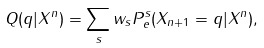<formula> <loc_0><loc_0><loc_500><loc_500>Q ( q | X ^ { n } ) = \sum _ { s } w _ { s } P _ { e } ^ { s } ( X _ { n + 1 } = q | X ^ { n } ) ,</formula> 